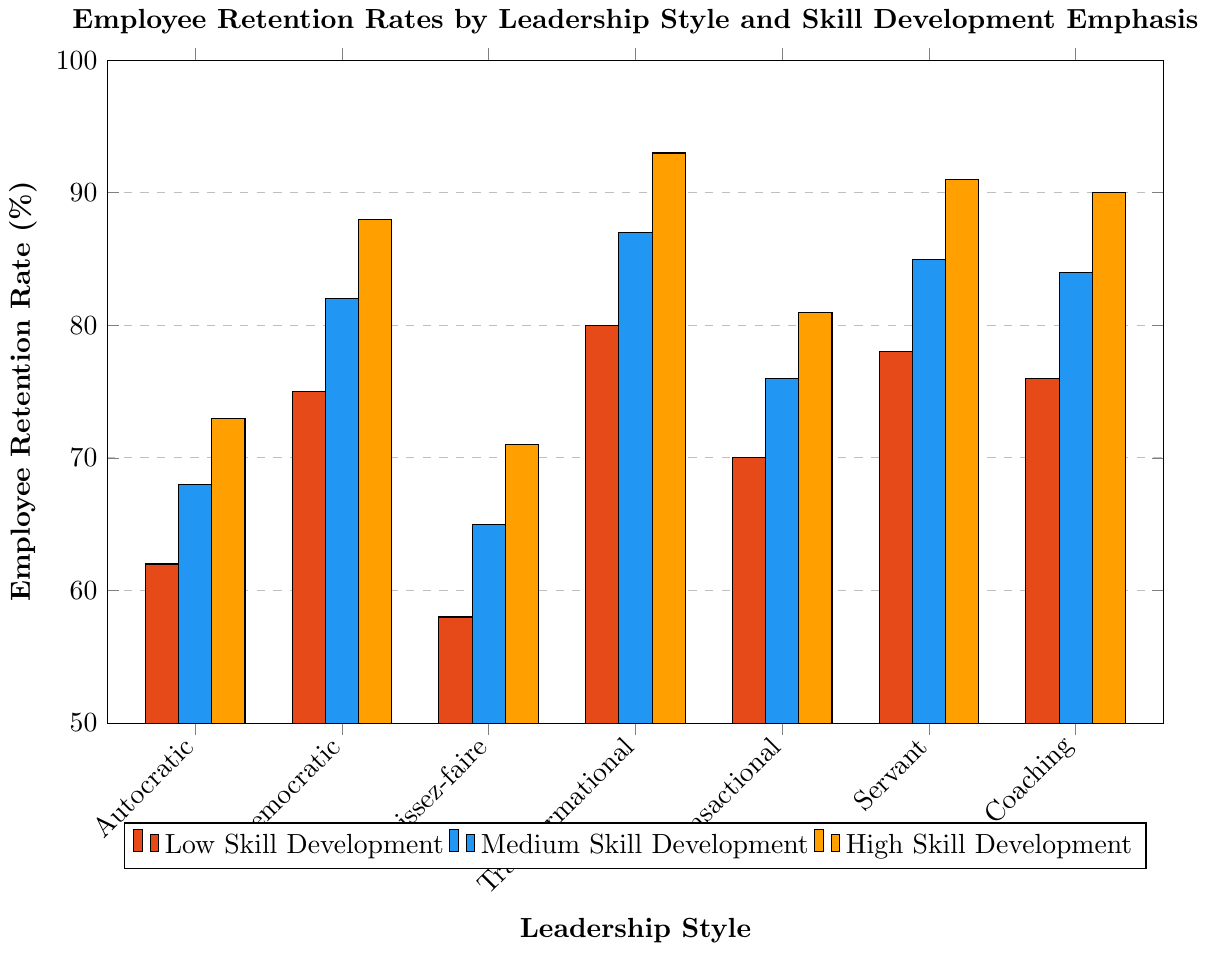What is the employee retention rate for the autocratic leadership style with high emphasis on skill development? The autocratic leadership style with high emphasis on skill development corresponds to the bar labeled "Autocratic" in the “High Skill Development” category. The height of this bar shows the retention rate.
Answer: 73% Which leadership style has the highest employee retention rate with low emphasis on skill development? To find this, look at the bars labeled “Low Skill Development” and identify the tallest bar among the different leadership styles. The tallest bar is for the transformational leadership style.
Answer: Transformational What is the difference in employee retention rates between democratic and laissez-faire leadership styles with medium emphasis on skill development? Locate the bars for democratic and laissez-faire leadership styles in the “Medium Skill Development” group. The retention rates are 82% and 65% respectively. Calculate the difference: 82% - 65% = 17%.
Answer: 17% Calculate the average retention rate for high emphasis on skill development across all leadership styles. Add the retention rates from the “High Skill Development” bars for each leadership style (73 + 88 + 71 + 93 + 81 + 91 + 90) and divide by the total number of leadership styles, which is 7. Average = (73 + 88 + 71 + 93 + 81 + 91 + 90)/7 = 83.2857.
Answer: 83.29% Which leadership style shows the greatest improvement in employee retention when moving from low to high emphasis on skill development? Calculate the difference in retention rates from low to high skill development for each leadership style and identify the one with the greatest difference.
Answer: Transformational What is the retention rate for the coaching leadership style with medium emphasis on skill development? Refer to the bar labeled “Coaching” in the “Medium Skill Development” group. The height of this bar indicates the retention rate.
Answer: 84% Compare the retention rates of transactional and servant leadership styles with high emphasis on skill development. Which one is higher? Look at the bars for transactional and servant leadership styles in the “High Skill Development” group. The retention rates are 81% and 91% respectively. The servant leadership style has a higher retention rate.
Answer: Servant Which leadership style has the lowest retention rate for low emphasis on skill development? Examine the bars labeled “Low Skill Development” and identify the shortest one among the different leadership styles. The shortest bar corresponds to the laissez-faire leadership style.
Answer: Laissez-faire What is the total retention rate for all leadership styles with medium emphasis on skill development? Add up the retention rates from the “Medium Skill Development” bars for each leadership style (68 + 82 + 65 + 87 + 76 + 85 + 84). Total = 68 + 82 + 65 + 87 + 76 + 85 + 84 = 547.
Answer: 547% Between autocratic and coaching leadership styles, which one has a higher retention rate when the emphasis on skill development is low? Compare the bars for autocratic and coaching leadership styles under the “Low Skill Development” category. The retention rates are 62% and 76% respectively, with coaching having a higher rate.
Answer: Coaching 